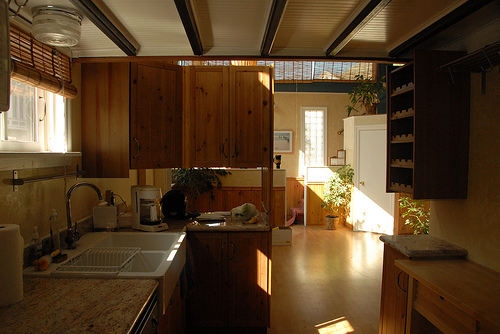<image>
Is there a sink next to the shelf? No. The sink is not positioned next to the shelf. They are located in different areas of the scene. 